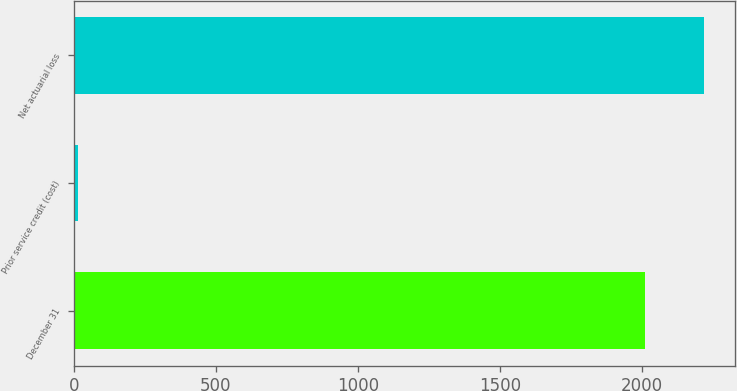Convert chart. <chart><loc_0><loc_0><loc_500><loc_500><bar_chart><fcel>December 31<fcel>Prior service credit (cost)<fcel>Net actuarial loss<nl><fcel>2011<fcel>14<fcel>2216.5<nl></chart> 